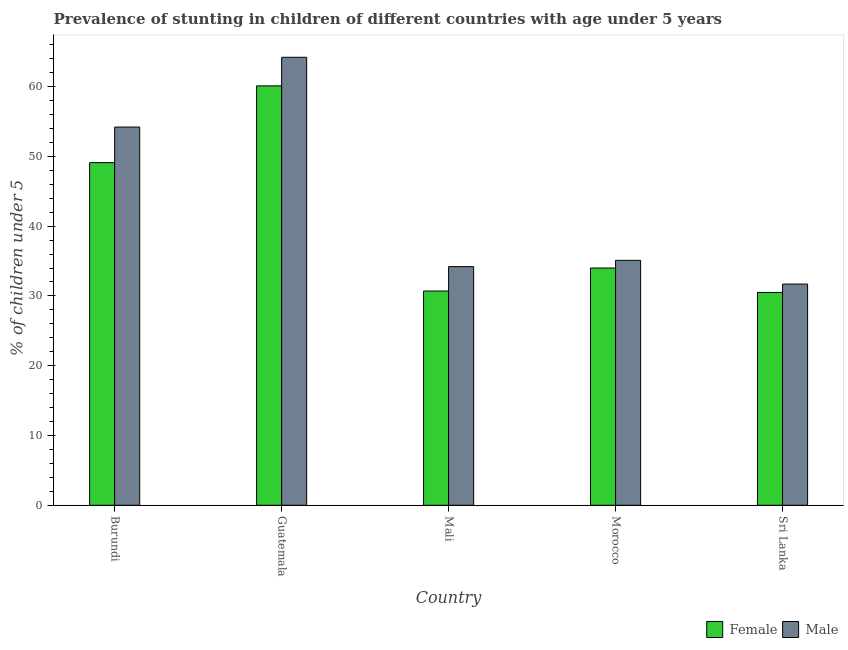Are the number of bars per tick equal to the number of legend labels?
Your response must be concise. Yes. How many bars are there on the 1st tick from the left?
Your answer should be compact. 2. How many bars are there on the 1st tick from the right?
Keep it short and to the point. 2. What is the label of the 4th group of bars from the left?
Provide a succinct answer. Morocco. What is the percentage of stunted female children in Mali?
Offer a very short reply. 30.7. Across all countries, what is the maximum percentage of stunted female children?
Give a very brief answer. 60.1. Across all countries, what is the minimum percentage of stunted male children?
Offer a terse response. 31.7. In which country was the percentage of stunted male children maximum?
Offer a very short reply. Guatemala. In which country was the percentage of stunted male children minimum?
Give a very brief answer. Sri Lanka. What is the total percentage of stunted male children in the graph?
Provide a short and direct response. 219.4. What is the difference between the percentage of stunted female children in Mali and that in Morocco?
Provide a succinct answer. -3.3. What is the difference between the percentage of stunted male children in Burundi and the percentage of stunted female children in Sri Lanka?
Offer a very short reply. 23.7. What is the average percentage of stunted male children per country?
Your response must be concise. 43.88. What is the difference between the percentage of stunted female children and percentage of stunted male children in Burundi?
Offer a very short reply. -5.1. In how many countries, is the percentage of stunted female children greater than 26 %?
Offer a terse response. 5. What is the ratio of the percentage of stunted male children in Burundi to that in Morocco?
Offer a very short reply. 1.54. What is the difference between the highest and the second highest percentage of stunted male children?
Make the answer very short. 10. What is the difference between the highest and the lowest percentage of stunted female children?
Your response must be concise. 29.6. Does the graph contain any zero values?
Provide a succinct answer. No. How many legend labels are there?
Your response must be concise. 2. What is the title of the graph?
Provide a short and direct response. Prevalence of stunting in children of different countries with age under 5 years. Does "Current education expenditure" appear as one of the legend labels in the graph?
Give a very brief answer. No. What is the label or title of the X-axis?
Ensure brevity in your answer.  Country. What is the label or title of the Y-axis?
Your answer should be very brief.  % of children under 5. What is the  % of children under 5 in Female in Burundi?
Your answer should be very brief. 49.1. What is the  % of children under 5 in Male in Burundi?
Make the answer very short. 54.2. What is the  % of children under 5 of Female in Guatemala?
Keep it short and to the point. 60.1. What is the  % of children under 5 in Male in Guatemala?
Provide a succinct answer. 64.2. What is the  % of children under 5 of Female in Mali?
Offer a very short reply. 30.7. What is the  % of children under 5 of Male in Mali?
Offer a terse response. 34.2. What is the  % of children under 5 of Female in Morocco?
Your answer should be very brief. 34. What is the  % of children under 5 of Male in Morocco?
Your answer should be compact. 35.1. What is the  % of children under 5 of Female in Sri Lanka?
Provide a succinct answer. 30.5. What is the  % of children under 5 of Male in Sri Lanka?
Your response must be concise. 31.7. Across all countries, what is the maximum  % of children under 5 of Female?
Give a very brief answer. 60.1. Across all countries, what is the maximum  % of children under 5 in Male?
Give a very brief answer. 64.2. Across all countries, what is the minimum  % of children under 5 of Female?
Give a very brief answer. 30.5. Across all countries, what is the minimum  % of children under 5 of Male?
Provide a short and direct response. 31.7. What is the total  % of children under 5 of Female in the graph?
Make the answer very short. 204.4. What is the total  % of children under 5 in Male in the graph?
Your answer should be very brief. 219.4. What is the difference between the  % of children under 5 in Female in Burundi and that in Morocco?
Offer a terse response. 15.1. What is the difference between the  % of children under 5 of Male in Burundi and that in Sri Lanka?
Provide a succinct answer. 22.5. What is the difference between the  % of children under 5 of Female in Guatemala and that in Mali?
Offer a very short reply. 29.4. What is the difference between the  % of children under 5 in Female in Guatemala and that in Morocco?
Keep it short and to the point. 26.1. What is the difference between the  % of children under 5 of Male in Guatemala and that in Morocco?
Your answer should be compact. 29.1. What is the difference between the  % of children under 5 in Female in Guatemala and that in Sri Lanka?
Your answer should be very brief. 29.6. What is the difference between the  % of children under 5 of Male in Guatemala and that in Sri Lanka?
Ensure brevity in your answer.  32.5. What is the difference between the  % of children under 5 in Male in Mali and that in Morocco?
Provide a short and direct response. -0.9. What is the difference between the  % of children under 5 in Male in Mali and that in Sri Lanka?
Ensure brevity in your answer.  2.5. What is the difference between the  % of children under 5 of Male in Morocco and that in Sri Lanka?
Your answer should be very brief. 3.4. What is the difference between the  % of children under 5 in Female in Burundi and the  % of children under 5 in Male in Guatemala?
Keep it short and to the point. -15.1. What is the difference between the  % of children under 5 of Female in Burundi and the  % of children under 5 of Male in Mali?
Offer a terse response. 14.9. What is the difference between the  % of children under 5 of Female in Burundi and the  % of children under 5 of Male in Morocco?
Give a very brief answer. 14. What is the difference between the  % of children under 5 in Female in Burundi and the  % of children under 5 in Male in Sri Lanka?
Your answer should be very brief. 17.4. What is the difference between the  % of children under 5 in Female in Guatemala and the  % of children under 5 in Male in Mali?
Your response must be concise. 25.9. What is the difference between the  % of children under 5 of Female in Guatemala and the  % of children under 5 of Male in Sri Lanka?
Provide a short and direct response. 28.4. What is the difference between the  % of children under 5 of Female in Mali and the  % of children under 5 of Male in Morocco?
Offer a very short reply. -4.4. What is the difference between the  % of children under 5 of Female in Morocco and the  % of children under 5 of Male in Sri Lanka?
Provide a succinct answer. 2.3. What is the average  % of children under 5 in Female per country?
Keep it short and to the point. 40.88. What is the average  % of children under 5 in Male per country?
Provide a short and direct response. 43.88. What is the difference between the  % of children under 5 in Female and  % of children under 5 in Male in Burundi?
Offer a very short reply. -5.1. What is the difference between the  % of children under 5 of Female and  % of children under 5 of Male in Guatemala?
Provide a succinct answer. -4.1. What is the difference between the  % of children under 5 in Female and  % of children under 5 in Male in Mali?
Give a very brief answer. -3.5. What is the difference between the  % of children under 5 of Female and  % of children under 5 of Male in Morocco?
Give a very brief answer. -1.1. What is the difference between the  % of children under 5 in Female and  % of children under 5 in Male in Sri Lanka?
Make the answer very short. -1.2. What is the ratio of the  % of children under 5 of Female in Burundi to that in Guatemala?
Make the answer very short. 0.82. What is the ratio of the  % of children under 5 in Male in Burundi to that in Guatemala?
Your response must be concise. 0.84. What is the ratio of the  % of children under 5 in Female in Burundi to that in Mali?
Provide a succinct answer. 1.6. What is the ratio of the  % of children under 5 of Male in Burundi to that in Mali?
Offer a very short reply. 1.58. What is the ratio of the  % of children under 5 of Female in Burundi to that in Morocco?
Keep it short and to the point. 1.44. What is the ratio of the  % of children under 5 of Male in Burundi to that in Morocco?
Keep it short and to the point. 1.54. What is the ratio of the  % of children under 5 in Female in Burundi to that in Sri Lanka?
Offer a very short reply. 1.61. What is the ratio of the  % of children under 5 in Male in Burundi to that in Sri Lanka?
Your response must be concise. 1.71. What is the ratio of the  % of children under 5 of Female in Guatemala to that in Mali?
Your answer should be compact. 1.96. What is the ratio of the  % of children under 5 of Male in Guatemala to that in Mali?
Ensure brevity in your answer.  1.88. What is the ratio of the  % of children under 5 in Female in Guatemala to that in Morocco?
Your answer should be very brief. 1.77. What is the ratio of the  % of children under 5 of Male in Guatemala to that in Morocco?
Offer a terse response. 1.83. What is the ratio of the  % of children under 5 of Female in Guatemala to that in Sri Lanka?
Provide a succinct answer. 1.97. What is the ratio of the  % of children under 5 in Male in Guatemala to that in Sri Lanka?
Provide a short and direct response. 2.03. What is the ratio of the  % of children under 5 of Female in Mali to that in Morocco?
Keep it short and to the point. 0.9. What is the ratio of the  % of children under 5 of Male in Mali to that in Morocco?
Provide a short and direct response. 0.97. What is the ratio of the  % of children under 5 in Female in Mali to that in Sri Lanka?
Offer a terse response. 1.01. What is the ratio of the  % of children under 5 of Male in Mali to that in Sri Lanka?
Provide a succinct answer. 1.08. What is the ratio of the  % of children under 5 of Female in Morocco to that in Sri Lanka?
Provide a succinct answer. 1.11. What is the ratio of the  % of children under 5 of Male in Morocco to that in Sri Lanka?
Ensure brevity in your answer.  1.11. What is the difference between the highest and the second highest  % of children under 5 in Female?
Give a very brief answer. 11. What is the difference between the highest and the lowest  % of children under 5 in Female?
Ensure brevity in your answer.  29.6. What is the difference between the highest and the lowest  % of children under 5 of Male?
Keep it short and to the point. 32.5. 